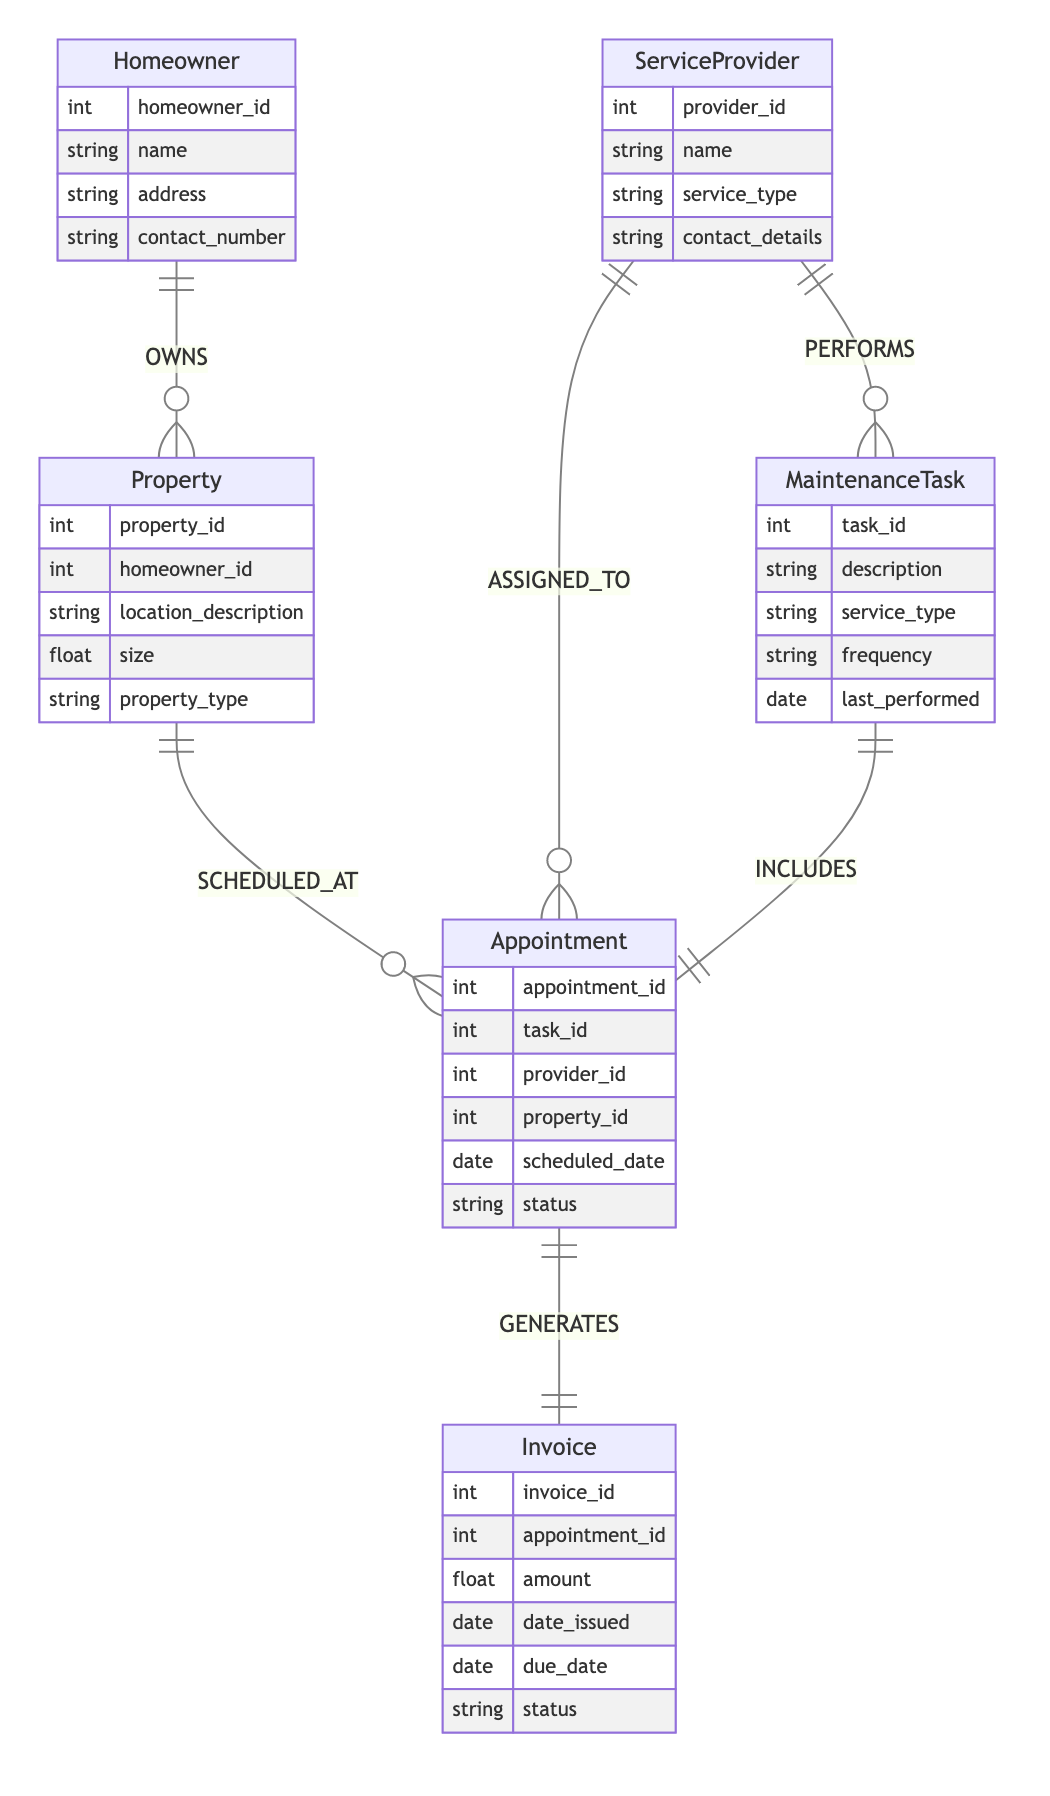What is the relationship between Homeowner and Property? The diagram shows that the relationship between Homeowner and Property is labeled as "OWNS" and is defined as a 1-to-Many relationship, indicating that one homeowner can own multiple properties.
Answer: OWNS How many attributes does the ServiceProvider entity have? By examining the ServiceProvider entity in the diagram, it contains four attributes: provider_id, name, service_type, and contact_details.
Answer: 4 What type of task does the ServiceProvider perform? The diagram indicates that the ServiceProvider entity has a relationship labeled "PERFORMS" with the MaintenanceTask entity, implying that the ServiceProvider performs Maintenance Tasks.
Answer: Maintenance Task What is the status of an Appointment? The Appointment entity shows that one of its attributes is "status," which indicates the current state of the appointment (e.g., scheduled, completed, canceled).
Answer: status How many types of relationships are shown in the diagram? By reviewing the connections depicted in the diagram, there are a total of six relationships specified: OWNS, PERFORMS, SCHEDULED_AT, ASSIGNED_TO, INCLUDES, and GENERATES.
Answer: 6 What generates an Invoice? The diagram states that the Appointment entity has a relationship labeled "GENERATES" with the Invoice entity, indicating that an appointment is responsible for generating an invoice.
Answer: Appointment Which entities have a one-to-many relationship? There are three pairs of entities with a one-to-many relationship: Homeowner to Property, ServiceProvider to MaintenanceTask, and Property to Appointment.
Answer: 3 What is the frequency of a MaintenanceTask? The MaintenanceTask entity includes an attribute called "frequency," which denotes how often the task should be completed, such as weekly, monthly, or yearly.
Answer: frequency How many properties can one Homeowner own? Given the 1-to-Many relationship defined as "OWNS," one Homeowner can own multiple properties; however, the exact number is not specified in the diagram, so it implies an unlimited potential.
Answer: Many 